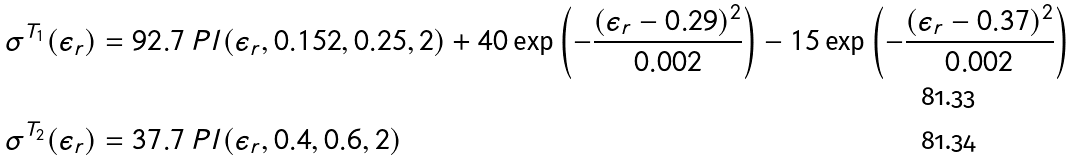Convert formula to latex. <formula><loc_0><loc_0><loc_500><loc_500>\sigma ^ { T _ { 1 } } ( \epsilon _ { r } ) & = 9 2 . 7 \, P l ( \epsilon _ { r } , 0 . 1 5 2 , 0 . 2 5 , 2 ) + 4 0 \exp \left ( - \frac { ( \epsilon _ { r } - 0 . 2 9 ) ^ { 2 } } { 0 . 0 0 2 } \right ) - 1 5 \exp \left ( - \frac { ( \epsilon _ { r } - 0 . 3 7 ) ^ { 2 } } { 0 . 0 0 2 } \right ) \\ \sigma ^ { T _ { 2 } } ( \epsilon _ { r } ) & = 3 7 . 7 \, P l ( \epsilon _ { r } , 0 . 4 , 0 . 6 , 2 )</formula> 